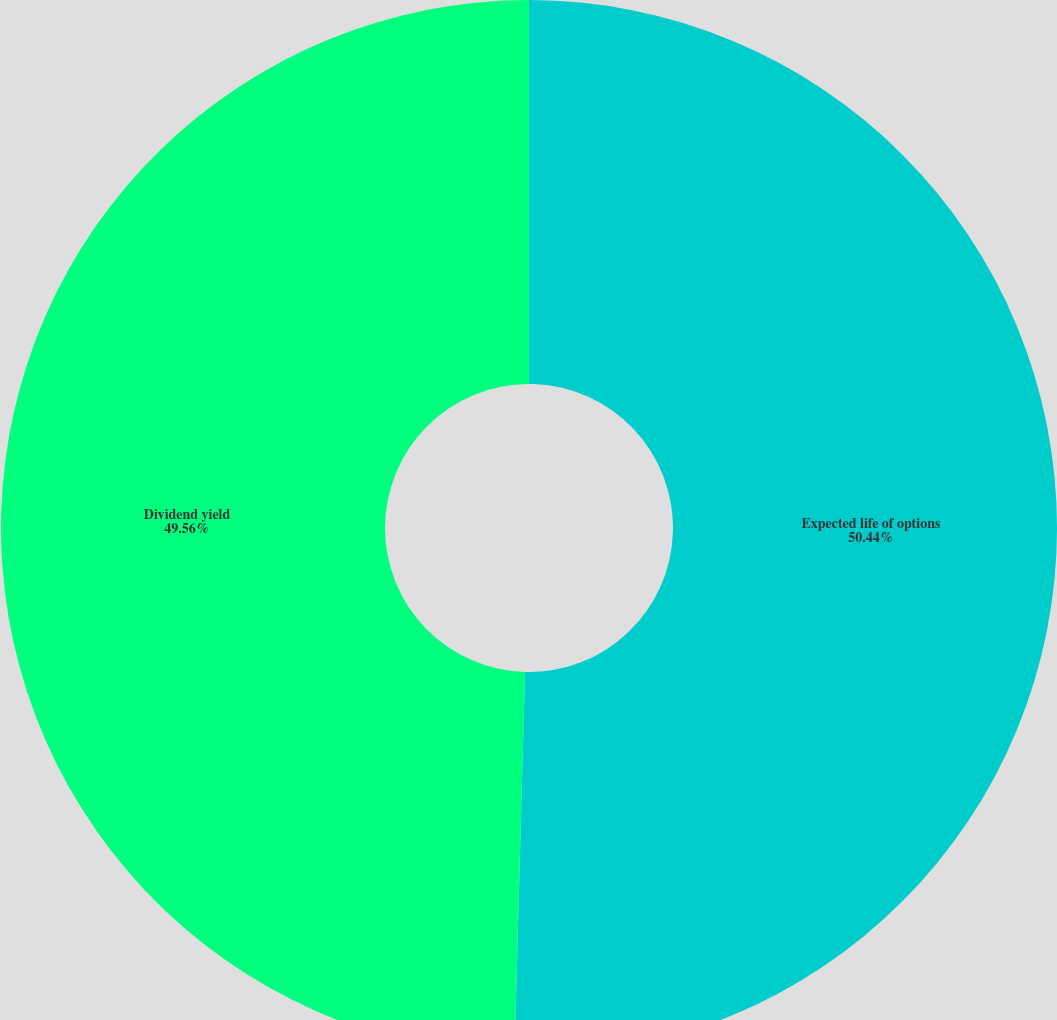<chart> <loc_0><loc_0><loc_500><loc_500><pie_chart><fcel>Expected life of options<fcel>Dividend yield<nl><fcel>50.44%<fcel>49.56%<nl></chart> 